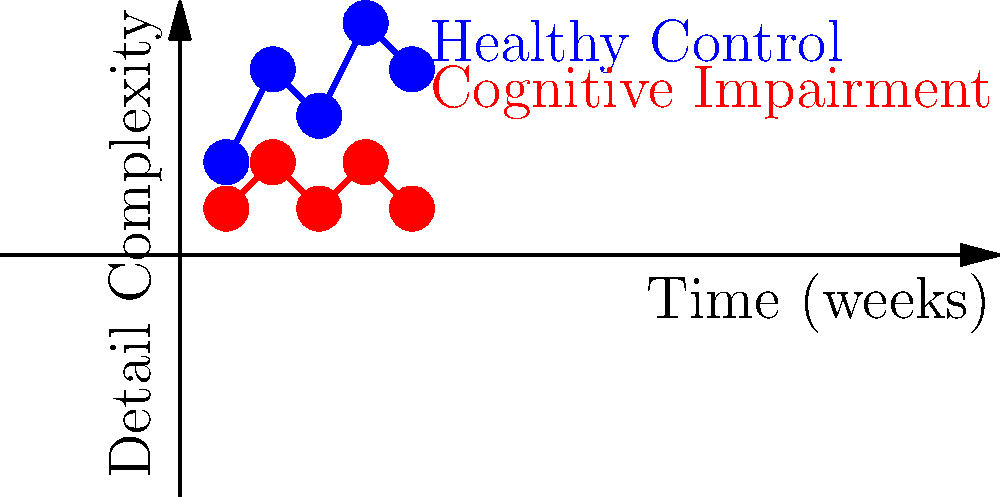Based on the graph showing the detail complexity in patient drawings over time, which line likely represents a patient with potential cognitive impairment, and what key feature supports this interpretation? To interpret this graph and identify potential cognitive impairment, we need to follow these steps:

1. Understand the axes:
   - X-axis represents time in weeks
   - Y-axis represents detail complexity in patient drawings

2. Observe the two lines:
   - Blue line: shows higher overall detail complexity and more variation
   - Red line: shows lower overall detail complexity and less variation

3. Consider the implications:
   - Higher detail complexity generally indicates better cognitive function
   - More variation in detail complexity suggests better adaptation and flexibility

4. Analyze the patterns:
   - The blue line demonstrates higher detail complexity (ranging from 2 to 5) and more variation over time
   - The red line shows consistently lower detail complexity (ranging from 1 to 2) and less variation

5. Apply knowledge of cognitive impairment:
   - Cognitive impairment often results in simplified drawings with less detail
   - Patients with cognitive impairment may struggle to adapt or vary their drawing complexity over time

6. Conclude:
   - The red line likely represents a patient with potential cognitive impairment due to:
     a) Consistently lower detail complexity
     b) Less variation in complexity over time

Therefore, the key feature supporting this interpretation is the consistently lower detail complexity shown by the red line.
Answer: Red line; consistently lower detail complexity 